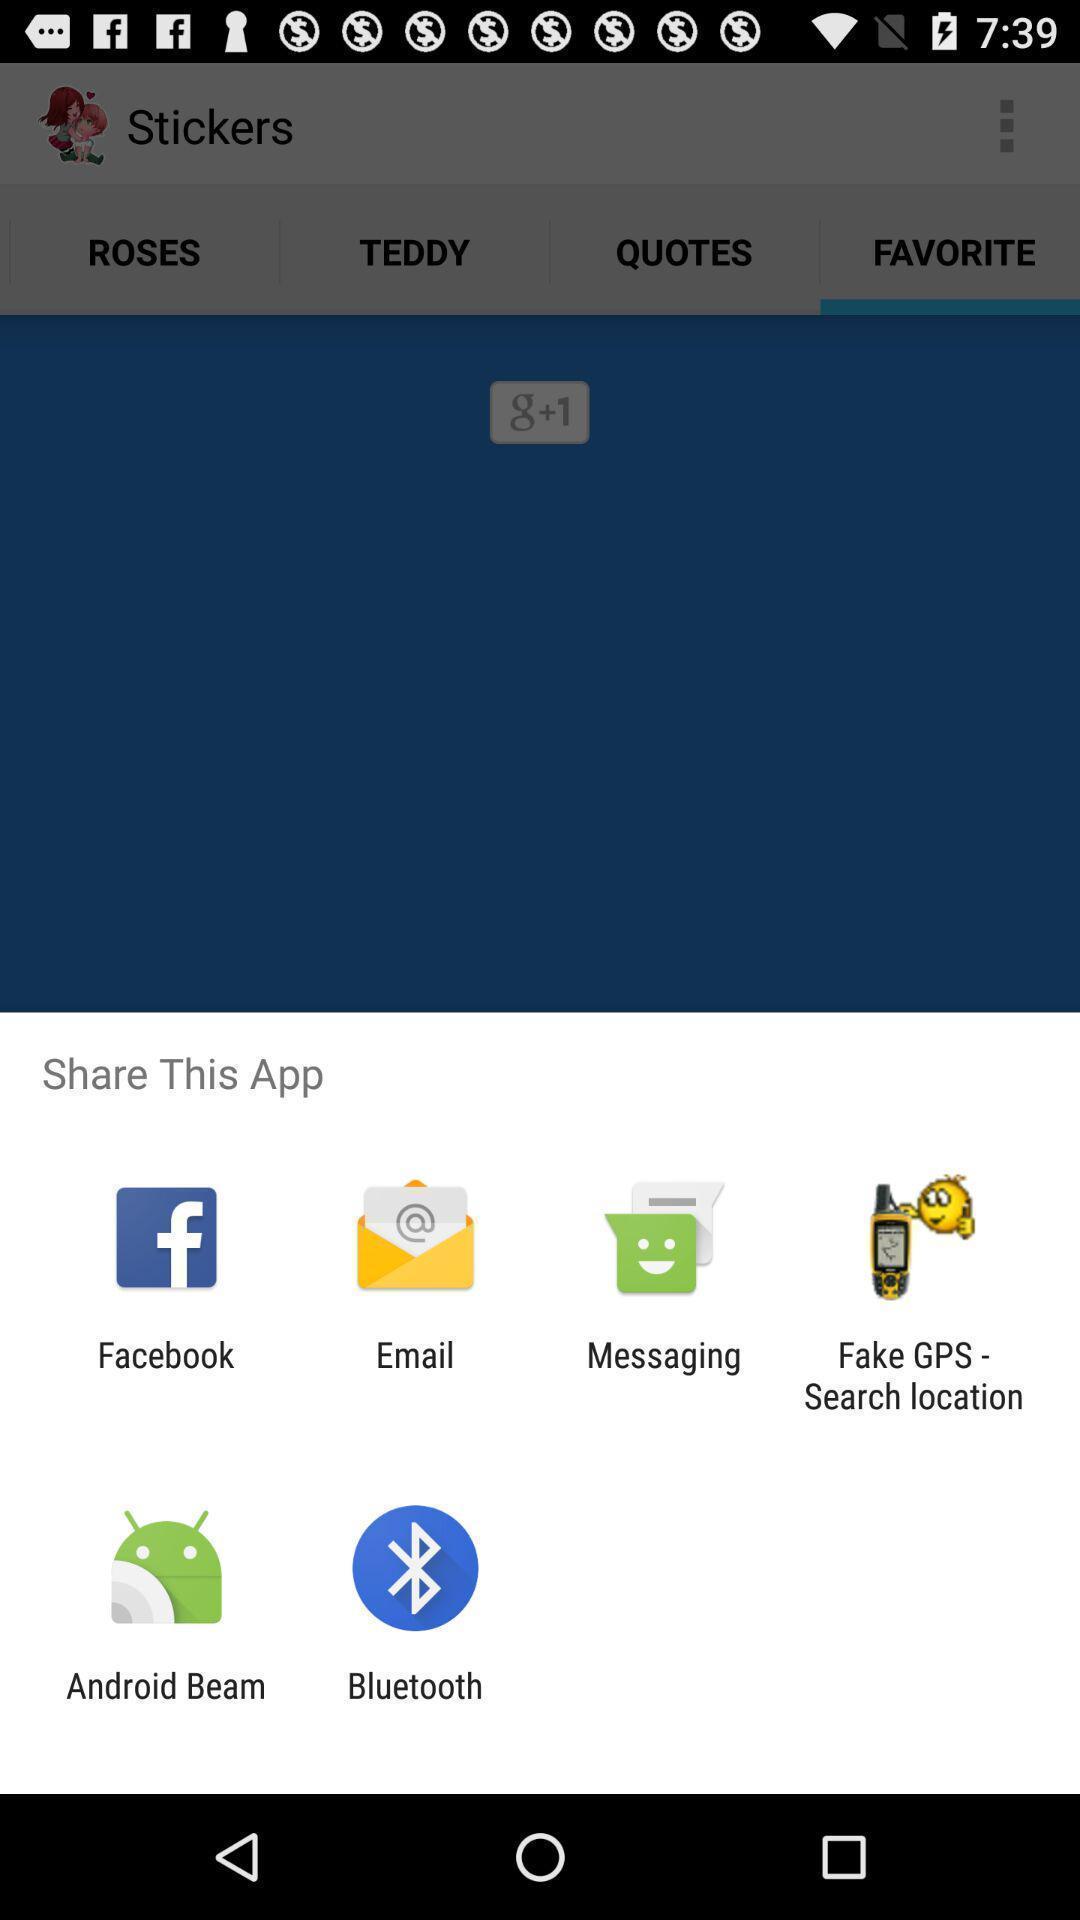Provide a textual representation of this image. Pop-up showing the various sharing options. 